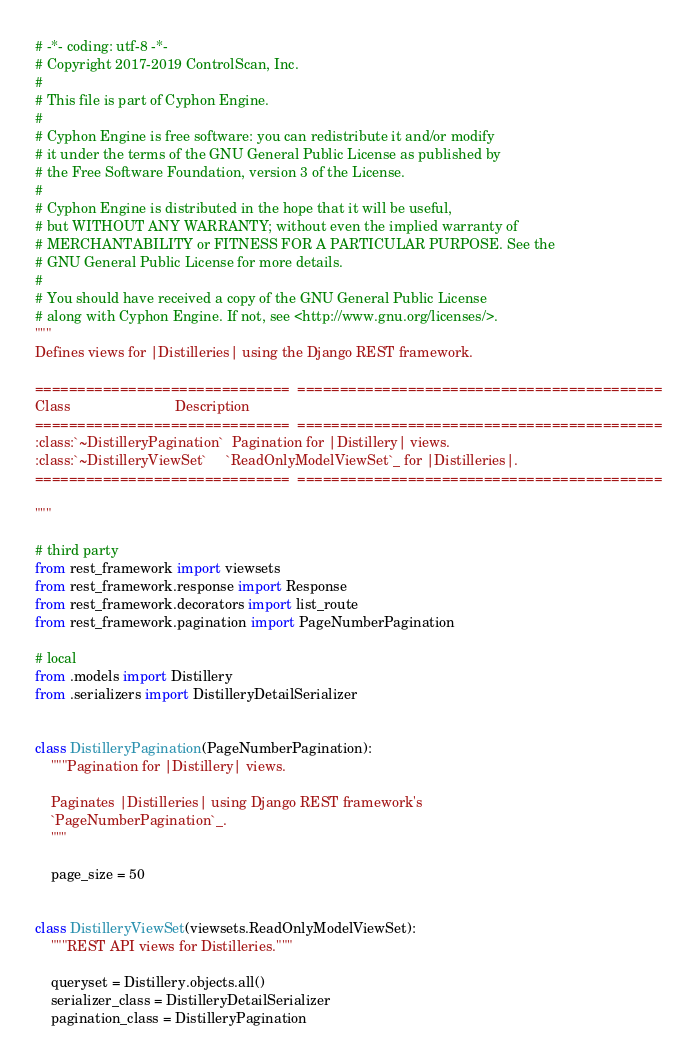Convert code to text. <code><loc_0><loc_0><loc_500><loc_500><_Python_># -*- coding: utf-8 -*-
# Copyright 2017-2019 ControlScan, Inc.
#
# This file is part of Cyphon Engine.
#
# Cyphon Engine is free software: you can redistribute it and/or modify
# it under the terms of the GNU General Public License as published by
# the Free Software Foundation, version 3 of the License.
#
# Cyphon Engine is distributed in the hope that it will be useful,
# but WITHOUT ANY WARRANTY; without even the implied warranty of
# MERCHANTABILITY or FITNESS FOR A PARTICULAR PURPOSE. See the
# GNU General Public License for more details.
#
# You should have received a copy of the GNU General Public License
# along with Cyphon Engine. If not, see <http://www.gnu.org/licenses/>.
"""
Defines views for |Distilleries| using the Django REST framework.

==============================  ===========================================
Class                           Description
==============================  ===========================================
:class:`~DistilleryPagination`  Pagination for |Distillery| views.
:class:`~DistilleryViewSet`     `ReadOnlyModelViewSet`_ for |Distilleries|.
==============================  ===========================================

"""

# third party
from rest_framework import viewsets
from rest_framework.response import Response
from rest_framework.decorators import list_route
from rest_framework.pagination import PageNumberPagination

# local
from .models import Distillery
from .serializers import DistilleryDetailSerializer


class DistilleryPagination(PageNumberPagination):
    """Pagination for |Distillery| views.

    Paginates |Distilleries| using Django REST framework's
    `PageNumberPagination`_.
    """

    page_size = 50


class DistilleryViewSet(viewsets.ReadOnlyModelViewSet):
    """REST API views for Distilleries."""

    queryset = Distillery.objects.all()
    serializer_class = DistilleryDetailSerializer
    pagination_class = DistilleryPagination
</code> 